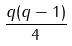Convert formula to latex. <formula><loc_0><loc_0><loc_500><loc_500>\frac { q ( q - 1 ) } { 4 }</formula> 